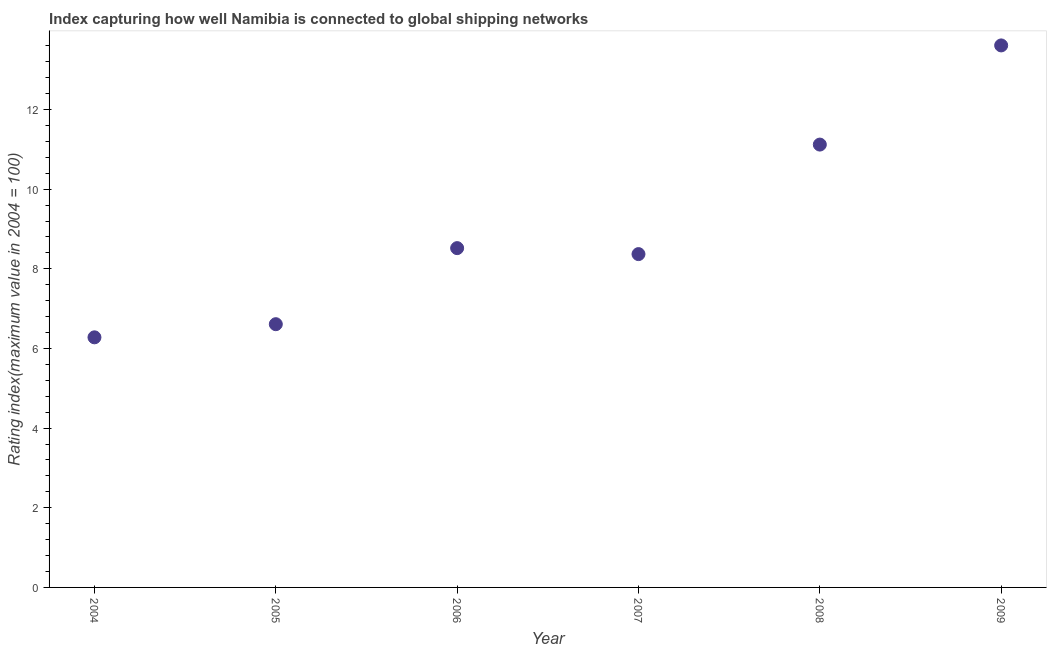What is the liner shipping connectivity index in 2005?
Offer a terse response. 6.61. Across all years, what is the maximum liner shipping connectivity index?
Your answer should be compact. 13.61. Across all years, what is the minimum liner shipping connectivity index?
Your answer should be very brief. 6.28. In which year was the liner shipping connectivity index maximum?
Make the answer very short. 2009. In which year was the liner shipping connectivity index minimum?
Offer a terse response. 2004. What is the sum of the liner shipping connectivity index?
Keep it short and to the point. 54.51. What is the difference between the liner shipping connectivity index in 2006 and 2007?
Make the answer very short. 0.15. What is the average liner shipping connectivity index per year?
Keep it short and to the point. 9.08. What is the median liner shipping connectivity index?
Give a very brief answer. 8.45. In how many years, is the liner shipping connectivity index greater than 4 ?
Your answer should be compact. 6. Do a majority of the years between 2009 and 2008 (inclusive) have liner shipping connectivity index greater than 7.2 ?
Keep it short and to the point. No. What is the ratio of the liner shipping connectivity index in 2005 to that in 2009?
Keep it short and to the point. 0.49. Is the difference between the liner shipping connectivity index in 2006 and 2009 greater than the difference between any two years?
Offer a terse response. No. What is the difference between the highest and the second highest liner shipping connectivity index?
Your response must be concise. 2.49. Is the sum of the liner shipping connectivity index in 2004 and 2006 greater than the maximum liner shipping connectivity index across all years?
Your response must be concise. Yes. What is the difference between the highest and the lowest liner shipping connectivity index?
Your response must be concise. 7.33. In how many years, is the liner shipping connectivity index greater than the average liner shipping connectivity index taken over all years?
Offer a very short reply. 2. How many years are there in the graph?
Offer a terse response. 6. Does the graph contain grids?
Give a very brief answer. No. What is the title of the graph?
Your answer should be compact. Index capturing how well Namibia is connected to global shipping networks. What is the label or title of the X-axis?
Offer a very short reply. Year. What is the label or title of the Y-axis?
Provide a succinct answer. Rating index(maximum value in 2004 = 100). What is the Rating index(maximum value in 2004 = 100) in 2004?
Keep it short and to the point. 6.28. What is the Rating index(maximum value in 2004 = 100) in 2005?
Provide a short and direct response. 6.61. What is the Rating index(maximum value in 2004 = 100) in 2006?
Your answer should be compact. 8.52. What is the Rating index(maximum value in 2004 = 100) in 2007?
Provide a short and direct response. 8.37. What is the Rating index(maximum value in 2004 = 100) in 2008?
Your answer should be very brief. 11.12. What is the Rating index(maximum value in 2004 = 100) in 2009?
Your answer should be very brief. 13.61. What is the difference between the Rating index(maximum value in 2004 = 100) in 2004 and 2005?
Offer a terse response. -0.33. What is the difference between the Rating index(maximum value in 2004 = 100) in 2004 and 2006?
Provide a short and direct response. -2.24. What is the difference between the Rating index(maximum value in 2004 = 100) in 2004 and 2007?
Offer a very short reply. -2.09. What is the difference between the Rating index(maximum value in 2004 = 100) in 2004 and 2008?
Your answer should be compact. -4.84. What is the difference between the Rating index(maximum value in 2004 = 100) in 2004 and 2009?
Offer a very short reply. -7.33. What is the difference between the Rating index(maximum value in 2004 = 100) in 2005 and 2006?
Provide a succinct answer. -1.91. What is the difference between the Rating index(maximum value in 2004 = 100) in 2005 and 2007?
Provide a short and direct response. -1.76. What is the difference between the Rating index(maximum value in 2004 = 100) in 2005 and 2008?
Your response must be concise. -4.51. What is the difference between the Rating index(maximum value in 2004 = 100) in 2005 and 2009?
Offer a terse response. -7. What is the difference between the Rating index(maximum value in 2004 = 100) in 2006 and 2007?
Keep it short and to the point. 0.15. What is the difference between the Rating index(maximum value in 2004 = 100) in 2006 and 2009?
Your answer should be compact. -5.09. What is the difference between the Rating index(maximum value in 2004 = 100) in 2007 and 2008?
Your answer should be compact. -2.75. What is the difference between the Rating index(maximum value in 2004 = 100) in 2007 and 2009?
Your answer should be compact. -5.24. What is the difference between the Rating index(maximum value in 2004 = 100) in 2008 and 2009?
Your answer should be very brief. -2.49. What is the ratio of the Rating index(maximum value in 2004 = 100) in 2004 to that in 2005?
Your response must be concise. 0.95. What is the ratio of the Rating index(maximum value in 2004 = 100) in 2004 to that in 2006?
Keep it short and to the point. 0.74. What is the ratio of the Rating index(maximum value in 2004 = 100) in 2004 to that in 2007?
Your answer should be compact. 0.75. What is the ratio of the Rating index(maximum value in 2004 = 100) in 2004 to that in 2008?
Ensure brevity in your answer.  0.56. What is the ratio of the Rating index(maximum value in 2004 = 100) in 2004 to that in 2009?
Offer a terse response. 0.46. What is the ratio of the Rating index(maximum value in 2004 = 100) in 2005 to that in 2006?
Offer a very short reply. 0.78. What is the ratio of the Rating index(maximum value in 2004 = 100) in 2005 to that in 2007?
Give a very brief answer. 0.79. What is the ratio of the Rating index(maximum value in 2004 = 100) in 2005 to that in 2008?
Offer a terse response. 0.59. What is the ratio of the Rating index(maximum value in 2004 = 100) in 2005 to that in 2009?
Offer a terse response. 0.49. What is the ratio of the Rating index(maximum value in 2004 = 100) in 2006 to that in 2007?
Provide a succinct answer. 1.02. What is the ratio of the Rating index(maximum value in 2004 = 100) in 2006 to that in 2008?
Ensure brevity in your answer.  0.77. What is the ratio of the Rating index(maximum value in 2004 = 100) in 2006 to that in 2009?
Offer a terse response. 0.63. What is the ratio of the Rating index(maximum value in 2004 = 100) in 2007 to that in 2008?
Offer a very short reply. 0.75. What is the ratio of the Rating index(maximum value in 2004 = 100) in 2007 to that in 2009?
Your answer should be very brief. 0.61. What is the ratio of the Rating index(maximum value in 2004 = 100) in 2008 to that in 2009?
Your answer should be very brief. 0.82. 